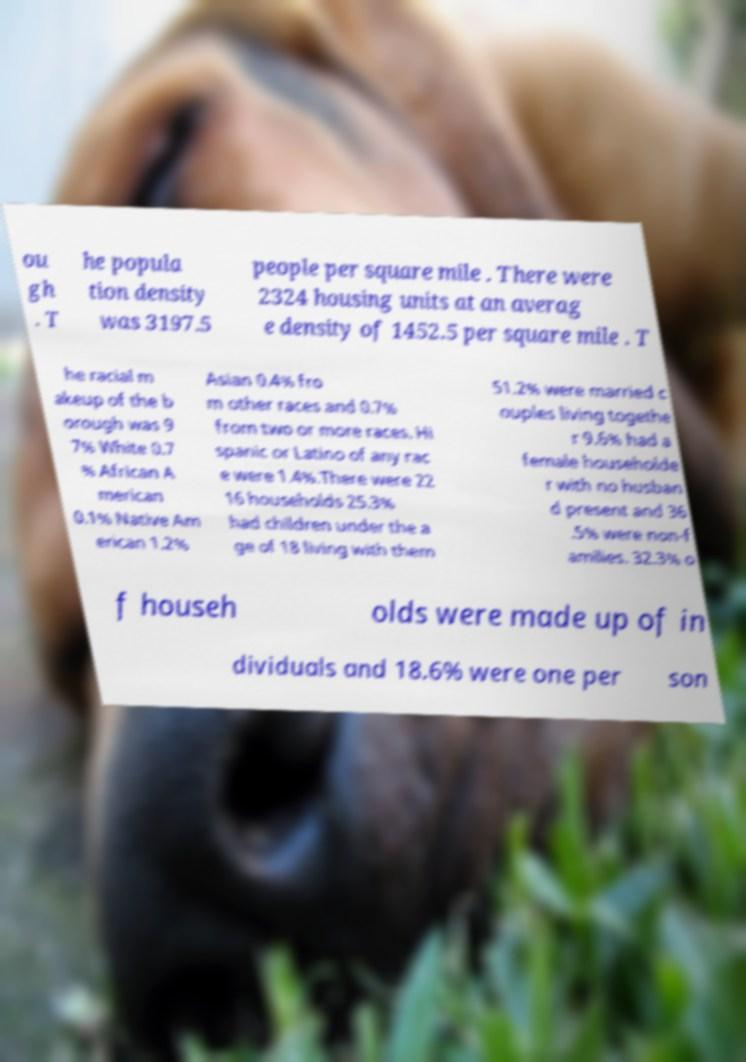Could you extract and type out the text from this image? ou gh . T he popula tion density was 3197.5 people per square mile . There were 2324 housing units at an averag e density of 1452.5 per square mile . T he racial m akeup of the b orough was 9 7% White 0.7 % African A merican 0.1% Native Am erican 1.2% Asian 0.4% fro m other races and 0.7% from two or more races. Hi spanic or Latino of any rac e were 1.4%.There were 22 16 households 25.3% had children under the a ge of 18 living with them 51.2% were married c ouples living togethe r 9.6% had a female householde r with no husban d present and 36 .5% were non-f amilies. 32.3% o f househ olds were made up of in dividuals and 18.6% were one per son 